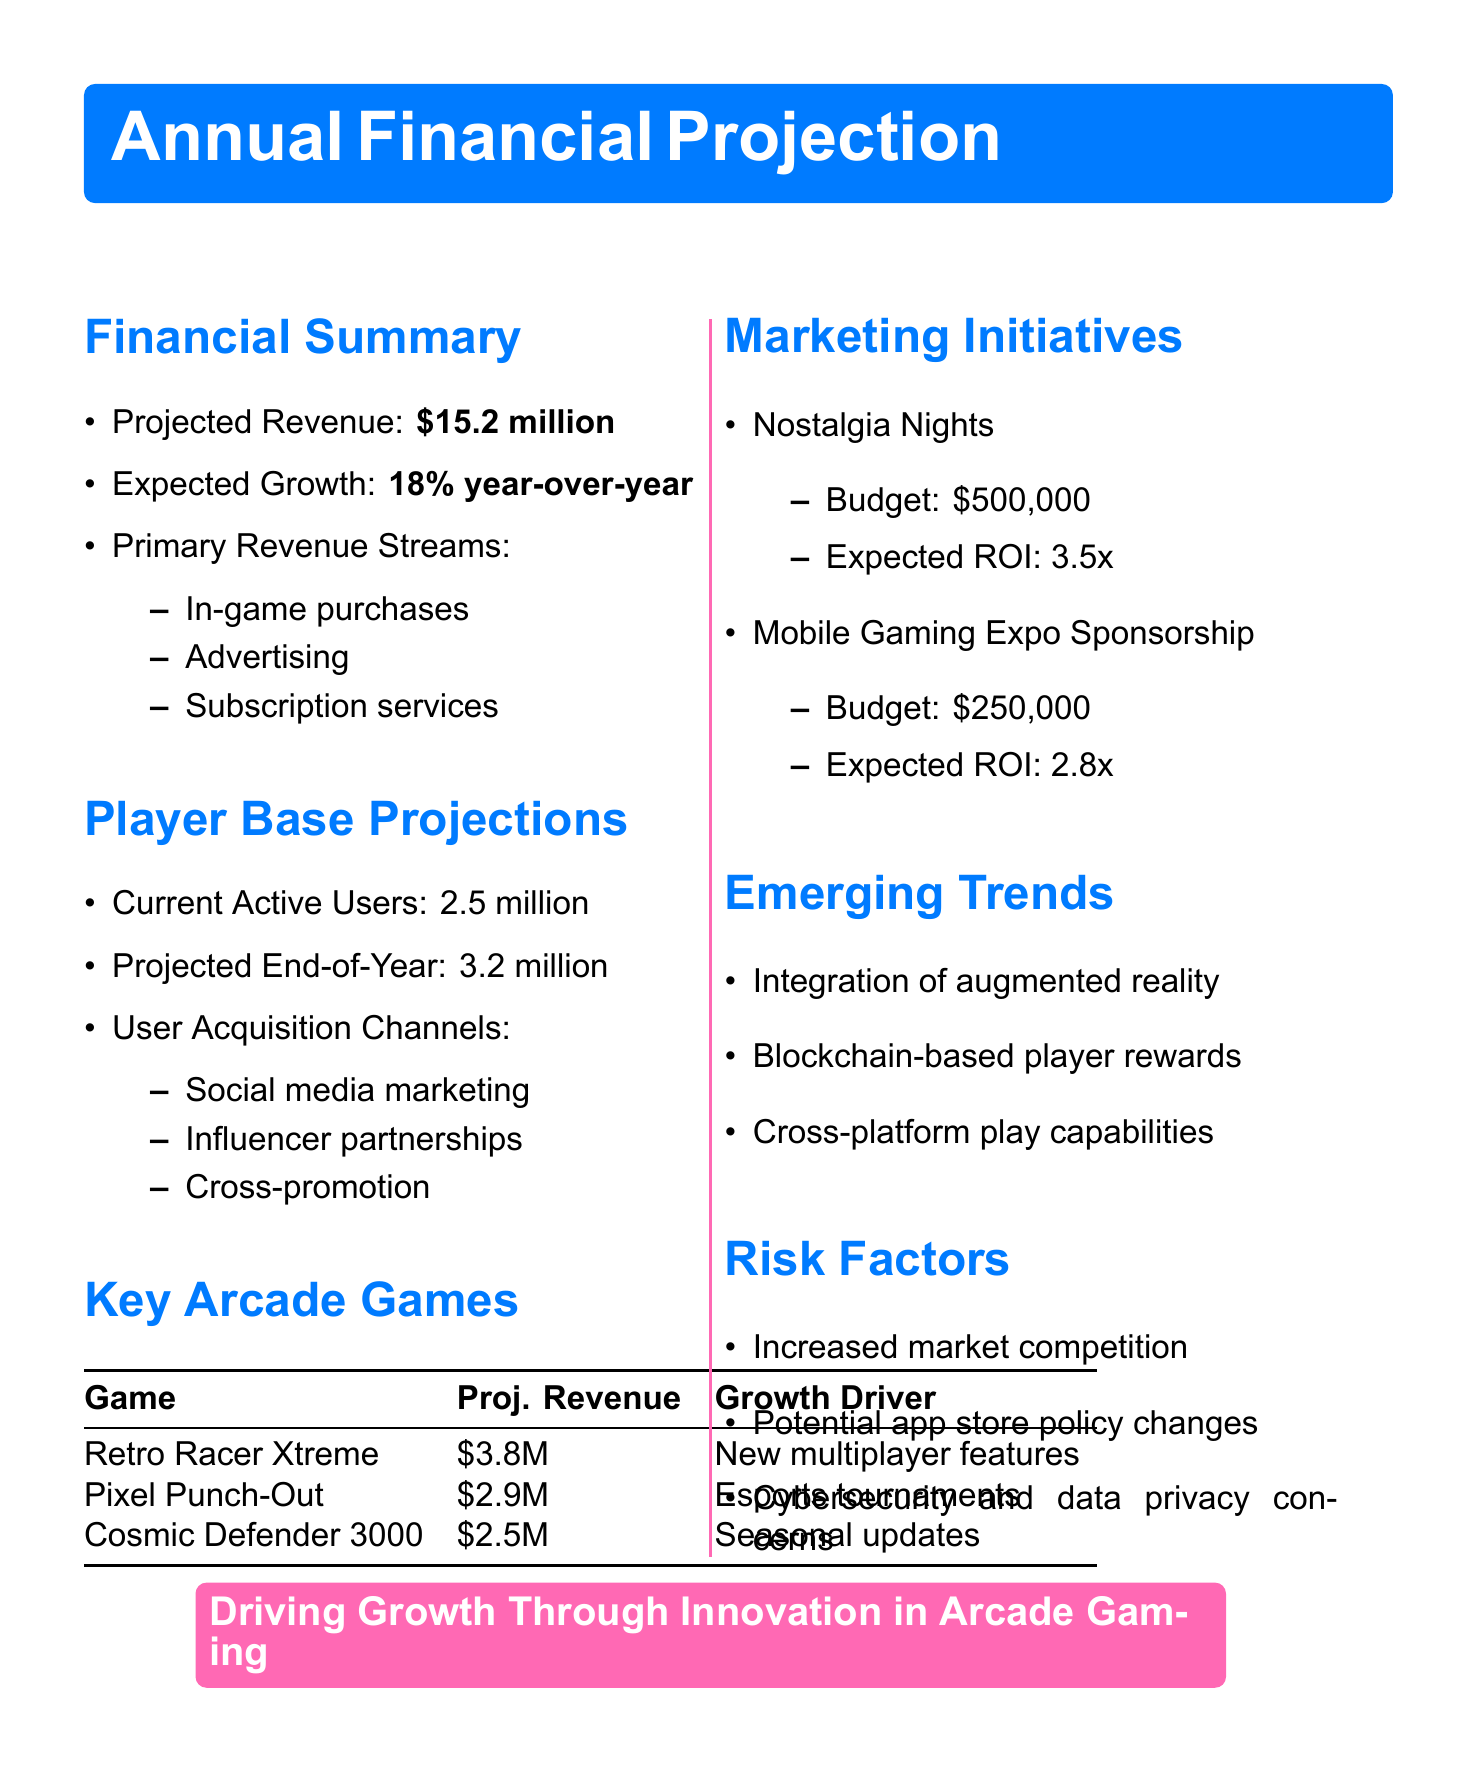What is the projected revenue for next year? The projected revenue is stated in the financial summary section of the document.
Answer: $15.2 million What is the expected growth rate? The expected growth rate is specified in the financial summary section of the document.
Answer: 18% year-over-year How many current active users are there? The number of current active users is presented in the player base projections section.
Answer: 2.5 million What is the projected end-of-year active users? The projected end-of-year active users is detailed in the player base projections section.
Answer: 3.2 million What revenue is anticipated from Retro Racer Xtreme? The projected revenue for Retro Racer Xtreme is given under key arcade games.
Answer: $3.8 million What is the budget for the Nostalgia Nights campaign? The budget for the Nostalgia Nights campaign is mentioned in the marketing initiatives section.
Answer: $500,000 What is one emerging trend mentioned in the report? Emerging trends are listed, and one can be selected from that list as specified in the document.
Answer: Integration of augmented reality features What risk factor relates to market conditions? The risk factors mentioned can be examined to identify one relating to market conditions.
Answer: Increased competition in the mobile gaming market What is the expected ROI for the Mobile Gaming Expo Sponsorship? The expected ROI for this sponsorship is detailed in the marketing initiatives section of the document.
Answer: 2.8x 